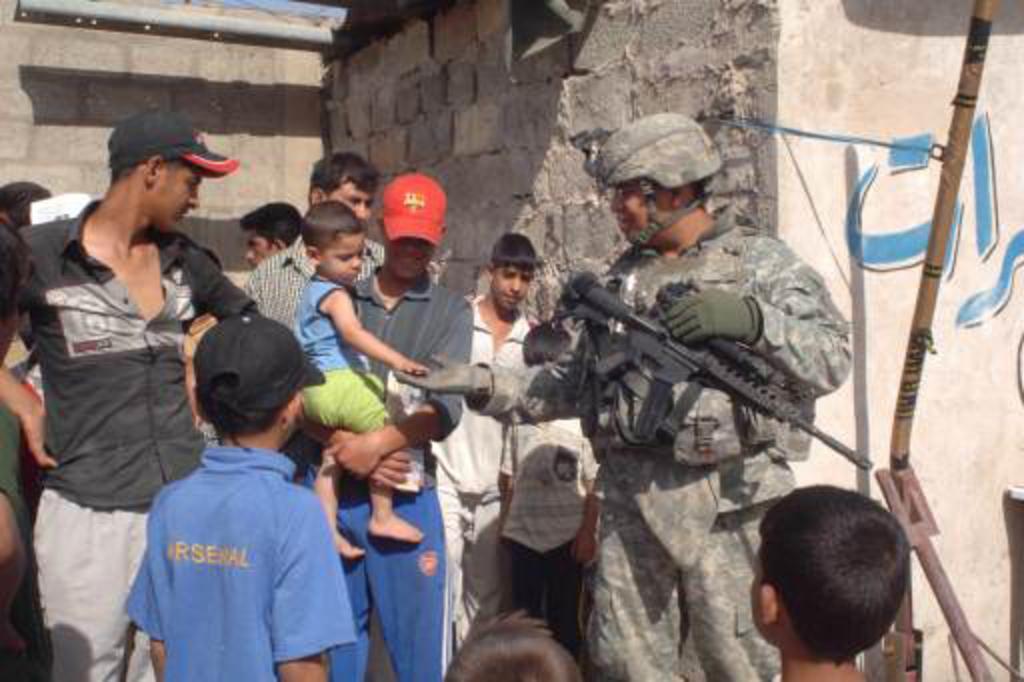Please provide a concise description of this image. In this picture I can see number of people in front who are standing and I can see a man on the center right of this picture who is wearing army uniform and is carrying a gun. In the background I can see the walls. 